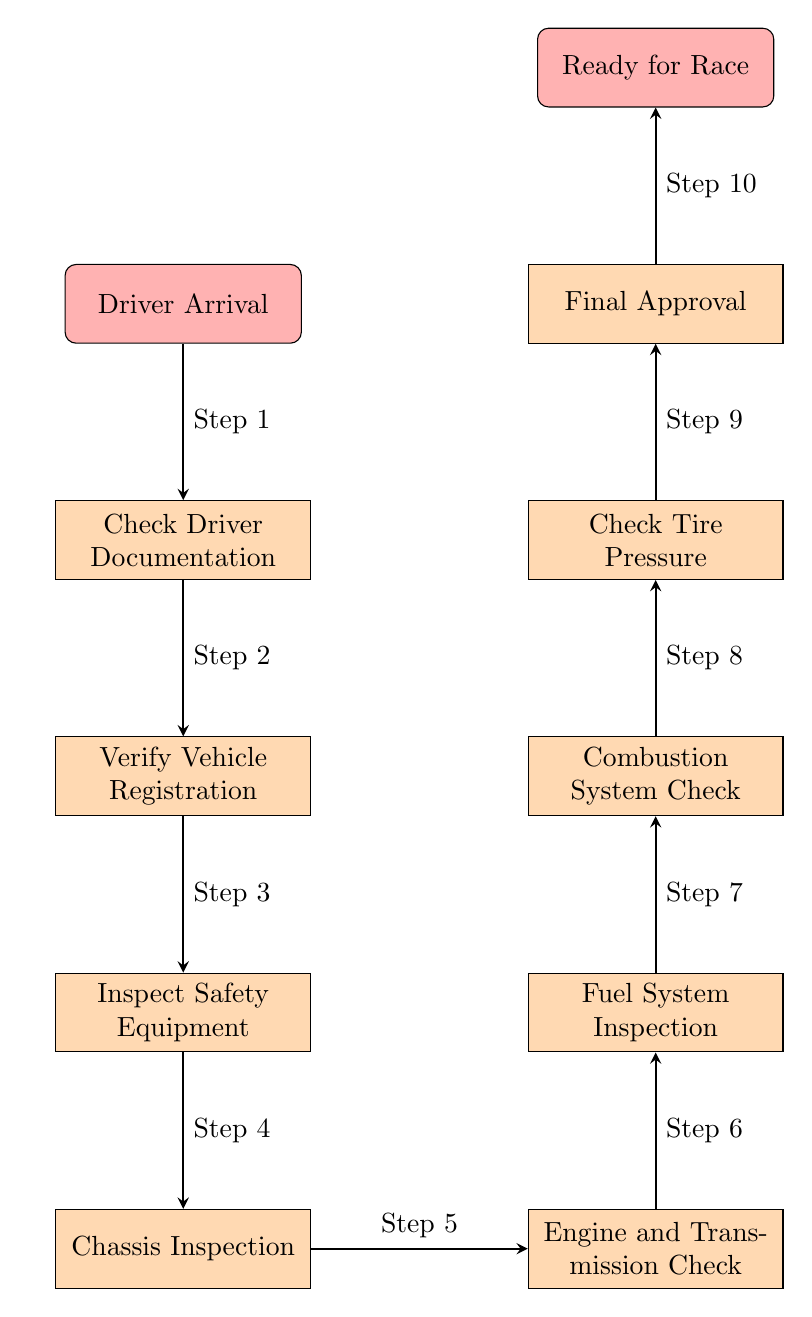What is the first step in the inspection process? The diagram lists "Driver Arrival" as the first node in the flowchart, indicating the starting point of the inspection process.
Answer: Driver Arrival How many total steps are in the vehicle inspection process? By examining the flowchart, we can count the number of nodes connected by arrows, which totals ten distinct steps in the process.
Answer: 10 What is the last step before being ready for the race? The diagram shows that "Final Approval" is the node right before "Ready for Race," making it the final step in the pre-race inspection process.
Answer: Final Approval Which inspection occurs directly after "Verify Vehicle Registration"? The flowchart indicates that "Inspect Safety Equipment" is the next step following "Verify Vehicle Registration," as it is connected by an arrow pointing downward.
Answer: Inspect Safety Equipment What check is done after the "Engine and Transmission Check"? According to the diagram, "Fuel System Inspection" follows the "Engine and Transmission Check," as denoted by the arrow leading from one to the other.
Answer: Fuel System Inspection How many inspections are in the vehicle inspection process? The inspection steps in the diagram include "Inspect Safety Equipment," "Chassis Inspection," "Engine and Transmission Check," "Fuel System Inspection," "Combustion System Check," "Check Tire Pressure," totaling six specific inspections.
Answer: 6 What is the flow of the vehicle inspection process? The flow starts with "Driver Arrival," followed by a sequence of checks leading to "Ready for Race." Each step follows the previous one in a linear manner connected by arrows, illustrating a clear inspection pathway.
Answer: Linear pathway What is checked first regarding the driver? The first check about the driver mentioned in the diagram is "Check Driver Documentation," immediately following "Driver Arrival" in the process flow.
Answer: Check Driver Documentation Which inspection step is located to the right of the Chassis Inspection? The diagram indicates that "Engine and Transmission Check" is the process located to the right of "Chassis Inspection," indicating it is a concurrent check in the flowchart.
Answer: Engine and Transmission Check 